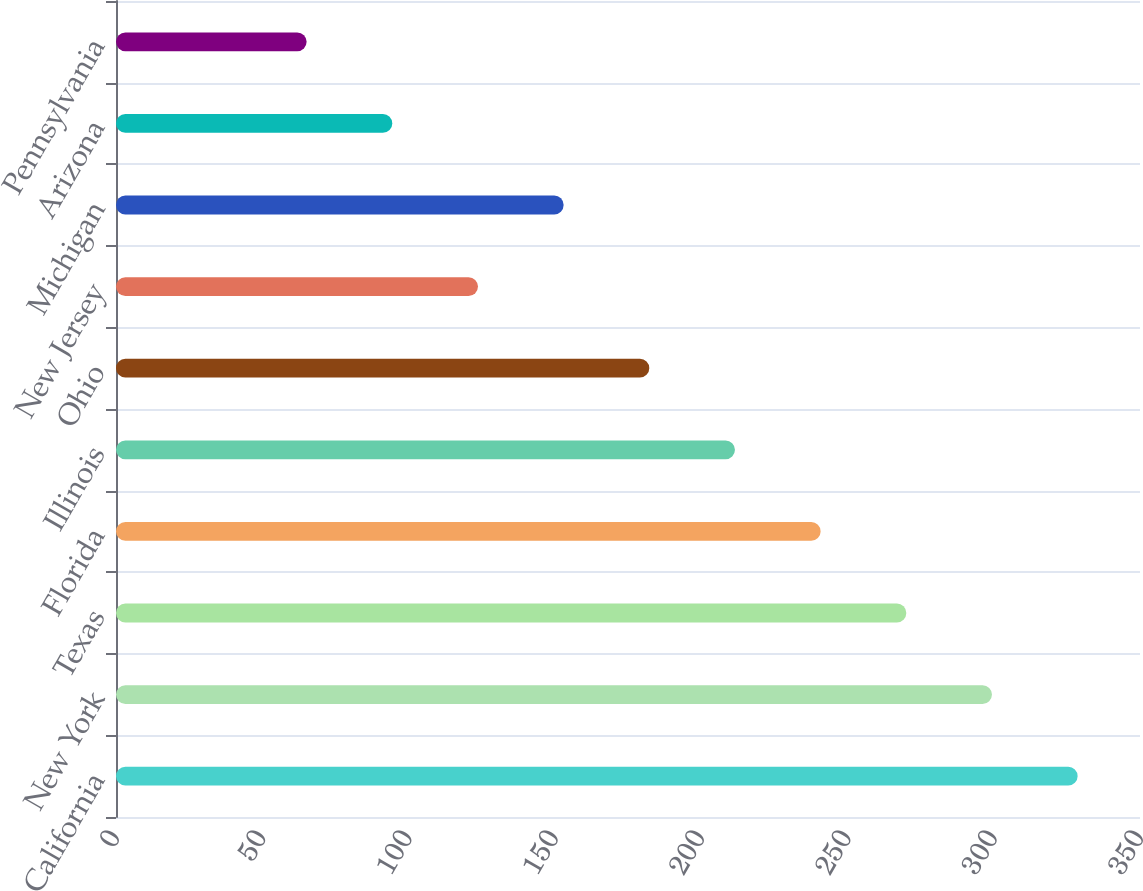Convert chart. <chart><loc_0><loc_0><loc_500><loc_500><bar_chart><fcel>California<fcel>New York<fcel>Texas<fcel>Florida<fcel>Illinois<fcel>Ohio<fcel>New Jersey<fcel>Michigan<fcel>Arizona<fcel>Pennsylvania<nl><fcel>328.68<fcel>299.4<fcel>270.12<fcel>240.84<fcel>211.56<fcel>182.28<fcel>123.72<fcel>153<fcel>94.44<fcel>65.16<nl></chart> 